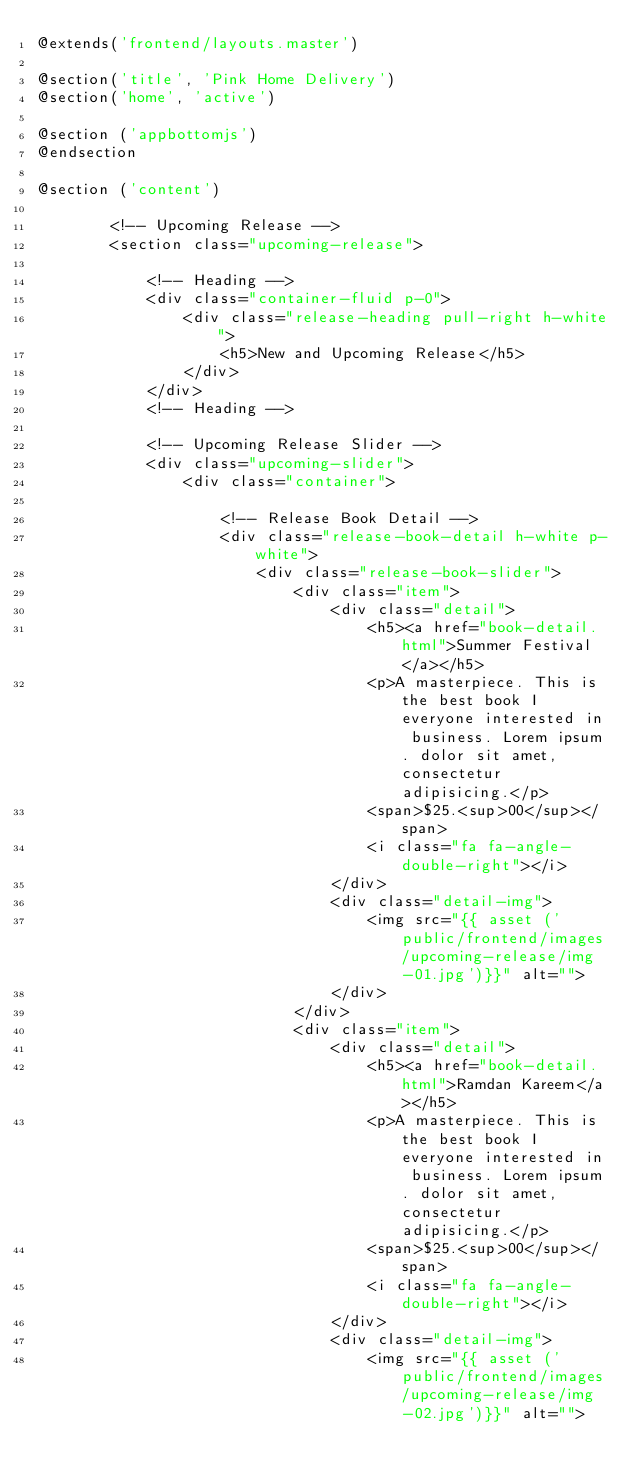<code> <loc_0><loc_0><loc_500><loc_500><_PHP_>@extends('frontend/layouts.master')

@section('title', 'Pink Home Delivery')
@section('home', 'active')

@section ('appbottomjs')
@endsection

@section ('content')
    
        <!-- Upcoming Release -->
        <section class="upcoming-release">

            <!-- Heading -->
            <div class="container-fluid p-0">
                <div class="release-heading pull-right h-white">
                    <h5>New and Upcoming Release</h5>
                </div>
            </div>
            <!-- Heading -->

            <!-- Upcoming Release Slider -->
            <div class="upcoming-slider">
                <div class="container">

                    <!-- Release Book Detail -->
                    <div class="release-book-detail h-white p-white">
                        <div class="release-book-slider">
                            <div class="item">
                                <div class="detail">
                                    <h5><a href="book-detail.html">Summer Festival</a></h5>
                                    <p>A masterpiece. This is the best book I everyone interested in business. Lorem ipsum. dolor sit amet, consectetur adipisicing.</p>
                                    <span>$25.<sup>00</sup></span>
                                    <i class="fa fa-angle-double-right"></i>
                                </div>
                                <div class="detail-img">
                                    <img src="{{ asset ('public/frontend/images/upcoming-release/img-01.jpg')}}" alt="">
                                </div>
                            </div>
                            <div class="item">
                                <div class="detail">
                                    <h5><a href="book-detail.html">Ramdan Kareem</a></h5>
                                    <p>A masterpiece. This is the best book I everyone interested in business. Lorem ipsum. dolor sit amet, consectetur adipisicing.</p>
                                    <span>$25.<sup>00</sup></span>
                                    <i class="fa fa-angle-double-right"></i>
                                </div>
                                <div class="detail-img">
                                    <img src="{{ asset ('public/frontend/images/upcoming-release/img-02.jpg')}}" alt=""></code> 